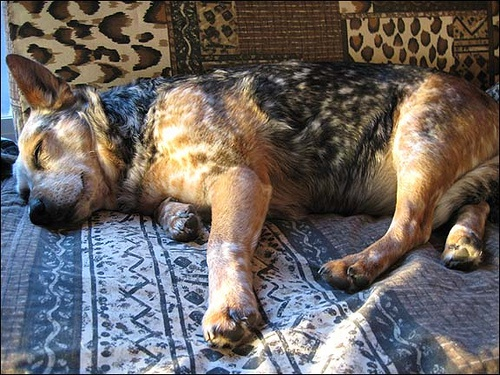Describe the objects in this image and their specific colors. I can see dog in black, gray, and maroon tones and bed in black, gray, darkgray, and blue tones in this image. 